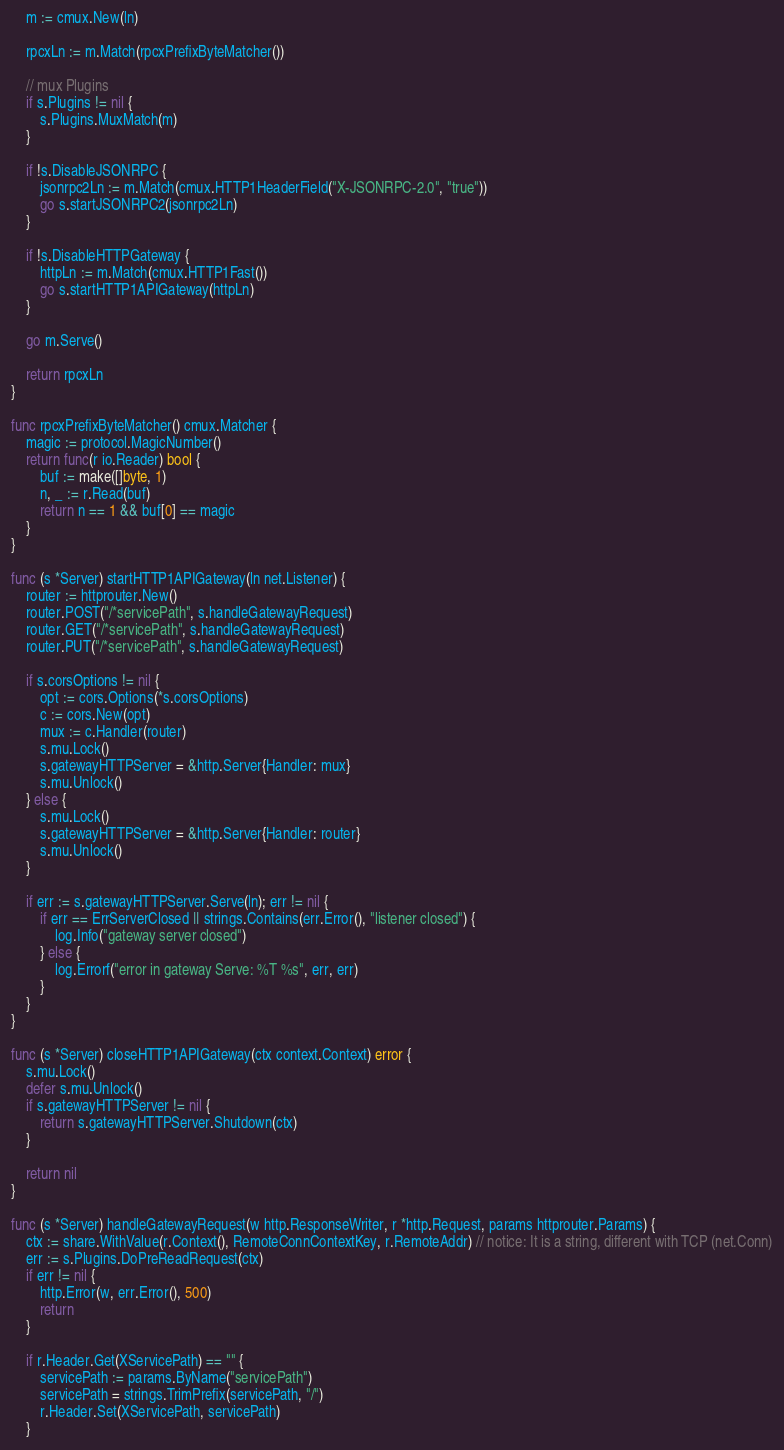Convert code to text. <code><loc_0><loc_0><loc_500><loc_500><_Go_>
	m := cmux.New(ln)

	rpcxLn := m.Match(rpcxPrefixByteMatcher())

	// mux Plugins
	if s.Plugins != nil {
		s.Plugins.MuxMatch(m)
	}

	if !s.DisableJSONRPC {
		jsonrpc2Ln := m.Match(cmux.HTTP1HeaderField("X-JSONRPC-2.0", "true"))
		go s.startJSONRPC2(jsonrpc2Ln)
	}

	if !s.DisableHTTPGateway {
		httpLn := m.Match(cmux.HTTP1Fast())
		go s.startHTTP1APIGateway(httpLn)
	}

	go m.Serve()

	return rpcxLn
}

func rpcxPrefixByteMatcher() cmux.Matcher {
	magic := protocol.MagicNumber()
	return func(r io.Reader) bool {
		buf := make([]byte, 1)
		n, _ := r.Read(buf)
		return n == 1 && buf[0] == magic
	}
}

func (s *Server) startHTTP1APIGateway(ln net.Listener) {
	router := httprouter.New()
	router.POST("/*servicePath", s.handleGatewayRequest)
	router.GET("/*servicePath", s.handleGatewayRequest)
	router.PUT("/*servicePath", s.handleGatewayRequest)

	if s.corsOptions != nil {
		opt := cors.Options(*s.corsOptions)
		c := cors.New(opt)
		mux := c.Handler(router)
		s.mu.Lock()
		s.gatewayHTTPServer = &http.Server{Handler: mux}
		s.mu.Unlock()
	} else {
		s.mu.Lock()
		s.gatewayHTTPServer = &http.Server{Handler: router}
		s.mu.Unlock()
	}

	if err := s.gatewayHTTPServer.Serve(ln); err != nil {
		if err == ErrServerClosed || strings.Contains(err.Error(), "listener closed") {
			log.Info("gateway server closed")
		} else {
			log.Errorf("error in gateway Serve: %T %s", err, err)
		}
	}
}

func (s *Server) closeHTTP1APIGateway(ctx context.Context) error {
	s.mu.Lock()
	defer s.mu.Unlock()
	if s.gatewayHTTPServer != nil {
		return s.gatewayHTTPServer.Shutdown(ctx)
	}

	return nil
}

func (s *Server) handleGatewayRequest(w http.ResponseWriter, r *http.Request, params httprouter.Params) {
	ctx := share.WithValue(r.Context(), RemoteConnContextKey, r.RemoteAddr) // notice: It is a string, different with TCP (net.Conn)
	err := s.Plugins.DoPreReadRequest(ctx)
	if err != nil {
		http.Error(w, err.Error(), 500)
		return
	}

	if r.Header.Get(XServicePath) == "" {
		servicePath := params.ByName("servicePath")
		servicePath = strings.TrimPrefix(servicePath, "/")
		r.Header.Set(XServicePath, servicePath)
	}</code> 